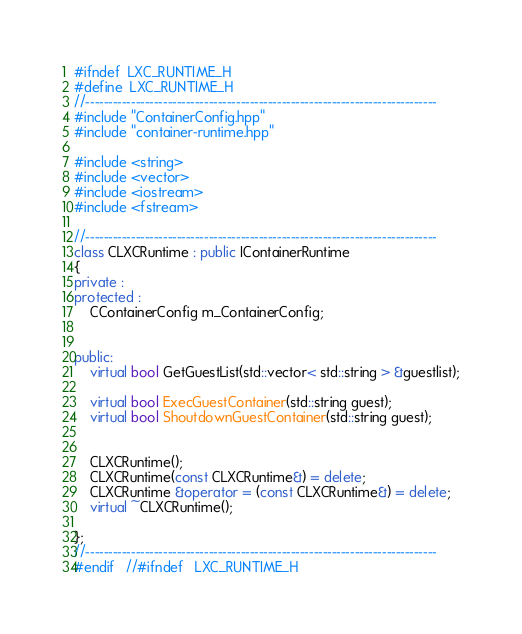<code> <loc_0><loc_0><loc_500><loc_500><_C++_>#ifndef	LXC_RUNTIME_H
#define	LXC_RUNTIME_H
//-----------------------------------------------------------------------------
#include "ContainerConfig.hpp"
#include "container-runtime.hpp"

#include <string>
#include <vector>
#include <iostream>
#include <fstream>

//-----------------------------------------------------------------------------
class CLXCRuntime : public IContainerRuntime
{
private :
protected :
	CContainerConfig m_ContainerConfig;
	
	
public:
	virtual bool GetGuestList(std::vector< std::string > &guestlist);
	
	virtual bool ExecGuestContainer(std::string guest);
	virtual bool ShoutdownGuestContainer(std::string guest);
	
	
	CLXCRuntime();
	CLXCRuntime(const CLXCRuntime&) = delete;
	CLXCRuntime &operator = (const CLXCRuntime&) = delete;
	virtual ~CLXCRuntime();

};
//-----------------------------------------------------------------------------
#endif	//#ifndef	LXC_RUNTIME_H
</code> 